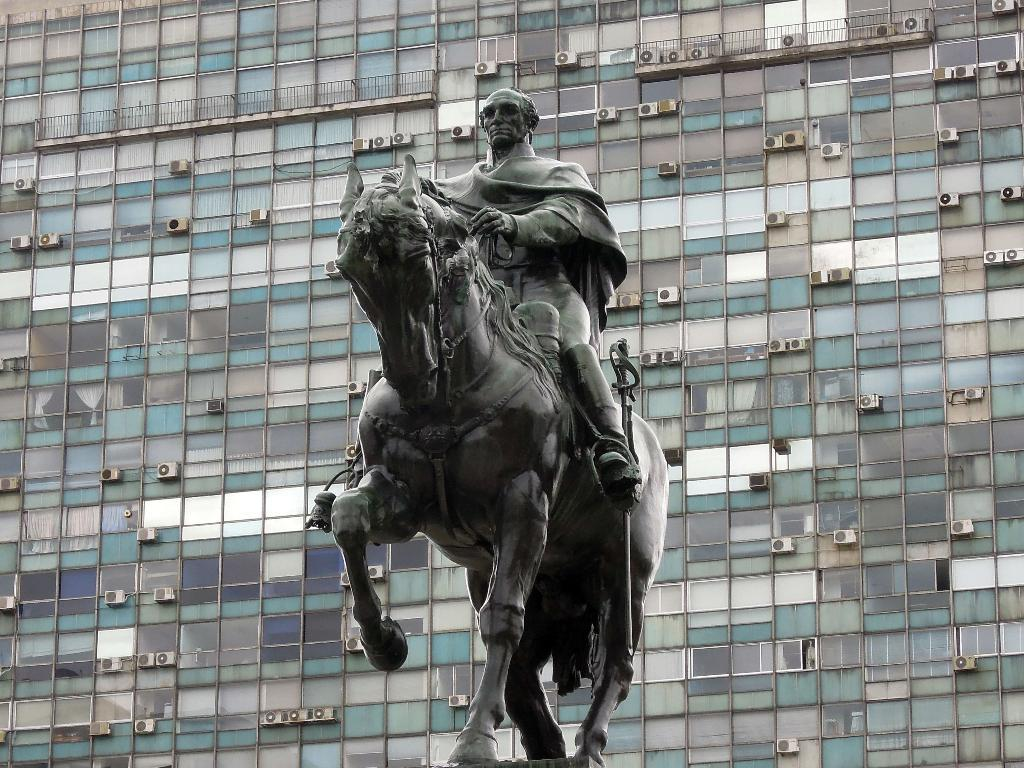What is the main subject of the image? There is a statue of a person in the image. How is the person depicted in the statue? The person is depicted as sitting on a horse. What can be seen in the background of the image? There is a building in the background of the image. Can you tell me how many coaches are parked near the statue in the image? There is no mention of coaches in the image; it features a statue of a person sitting on a horse with a building in the background. 